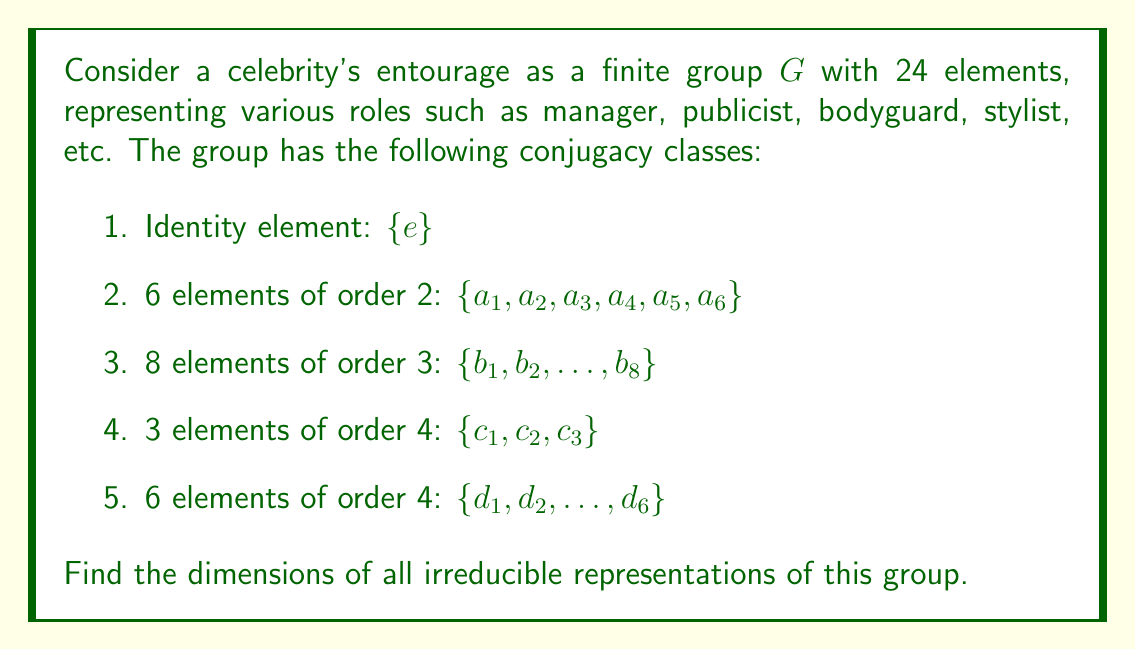Show me your answer to this math problem. To find the dimensions of irreducible representations, we'll use the following steps:

1) First, recall that the number of irreducible representations is equal to the number of conjugacy classes. Here, we have 5 conjugacy classes.

2) Let's denote the dimensions of these irreducible representations as $d_1, d_2, d_3, d_4, d_5$.

3) We know that the sum of squares of these dimensions must equal the order of the group:

   $$d_1^2 + d_2^2 + d_3^2 + d_4^2 + d_5^2 = |G| = 24$$

4) We also know that one of these representations is always the trivial representation with dimension 1. So $d_1 = 1$.

5) The number of elements in each conjugacy class gives us information about the character table. The sum of squares of entries in each column of the character table must equal $|G| = 24$.

6) For the identity element, this means:

   $$1^2 + d_2^2 + d_3^2 + d_4^2 + d_5^2 = 24$$

7) Comparing this with the equation from step 3, we can see that this equation must hold for all irreducible representations.

8) Given the sizes of the conjugacy classes, it's likely that the remaining dimensions are 1, 2, 2, and 3.

9) We can verify: $1^2 + 1^2 + 2^2 + 2^2 + 3^2 = 1 + 1 + 4 + 4 + 9 = 19$

10) Indeed, this satisfies our equation: $1 + 1 + 4 + 4 + 9 = 19 = 24 - 5 = |G| - \text{number of conjugacy classes}$

Therefore, the dimensions of the irreducible representations are 1, 1, 2, 2, and 3.
Answer: $1, 1, 2, 2, 3$ 